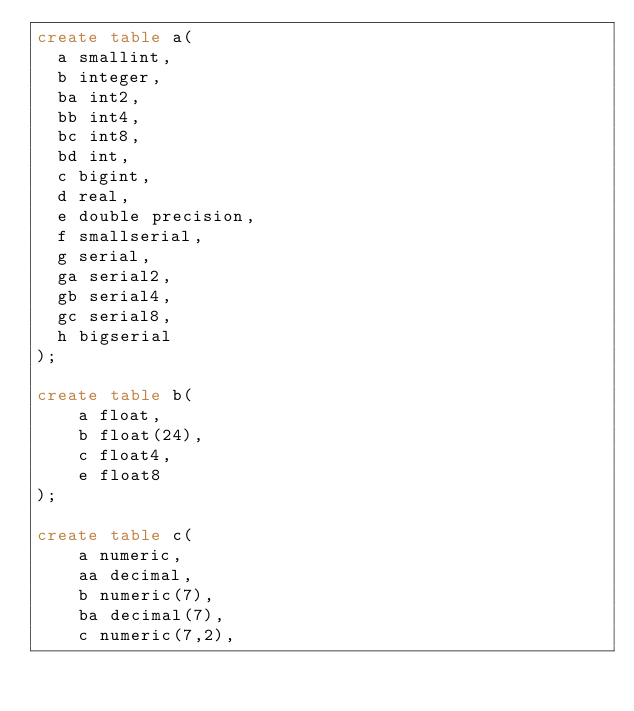Convert code to text. <code><loc_0><loc_0><loc_500><loc_500><_SQL_>create table a(
  a smallint,
  b integer,
  ba int2,
  bb int4,
  bc int8,
  bd int,
  c bigint,
  d real,
  e double precision,
  f smallserial,
  g serial,
  ga serial2,
  gb serial4,
  gc serial8,
  h bigserial
);

create table b(
    a float,
    b float(24),
    c float4,
    e float8
);

create table c(
    a numeric,
    aa decimal,
    b numeric(7),
    ba decimal(7),
    c numeric(7,2),</code> 